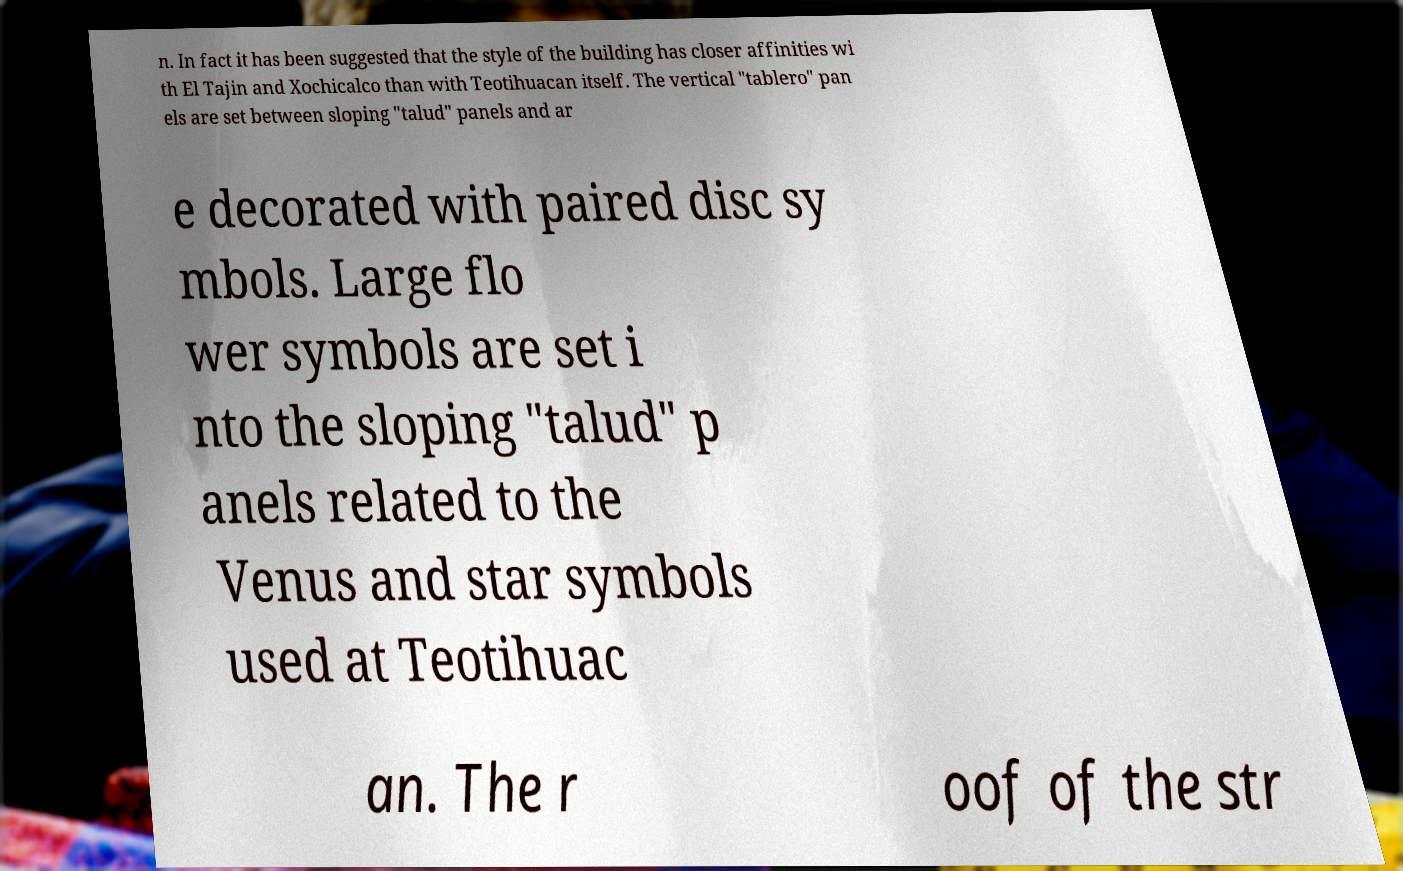Please identify and transcribe the text found in this image. n. In fact it has been suggested that the style of the building has closer affinities wi th El Tajin and Xochicalco than with Teotihuacan itself. The vertical "tablero" pan els are set between sloping "talud" panels and ar e decorated with paired disc sy mbols. Large flo wer symbols are set i nto the sloping "talud" p anels related to the Venus and star symbols used at Teotihuac an. The r oof of the str 